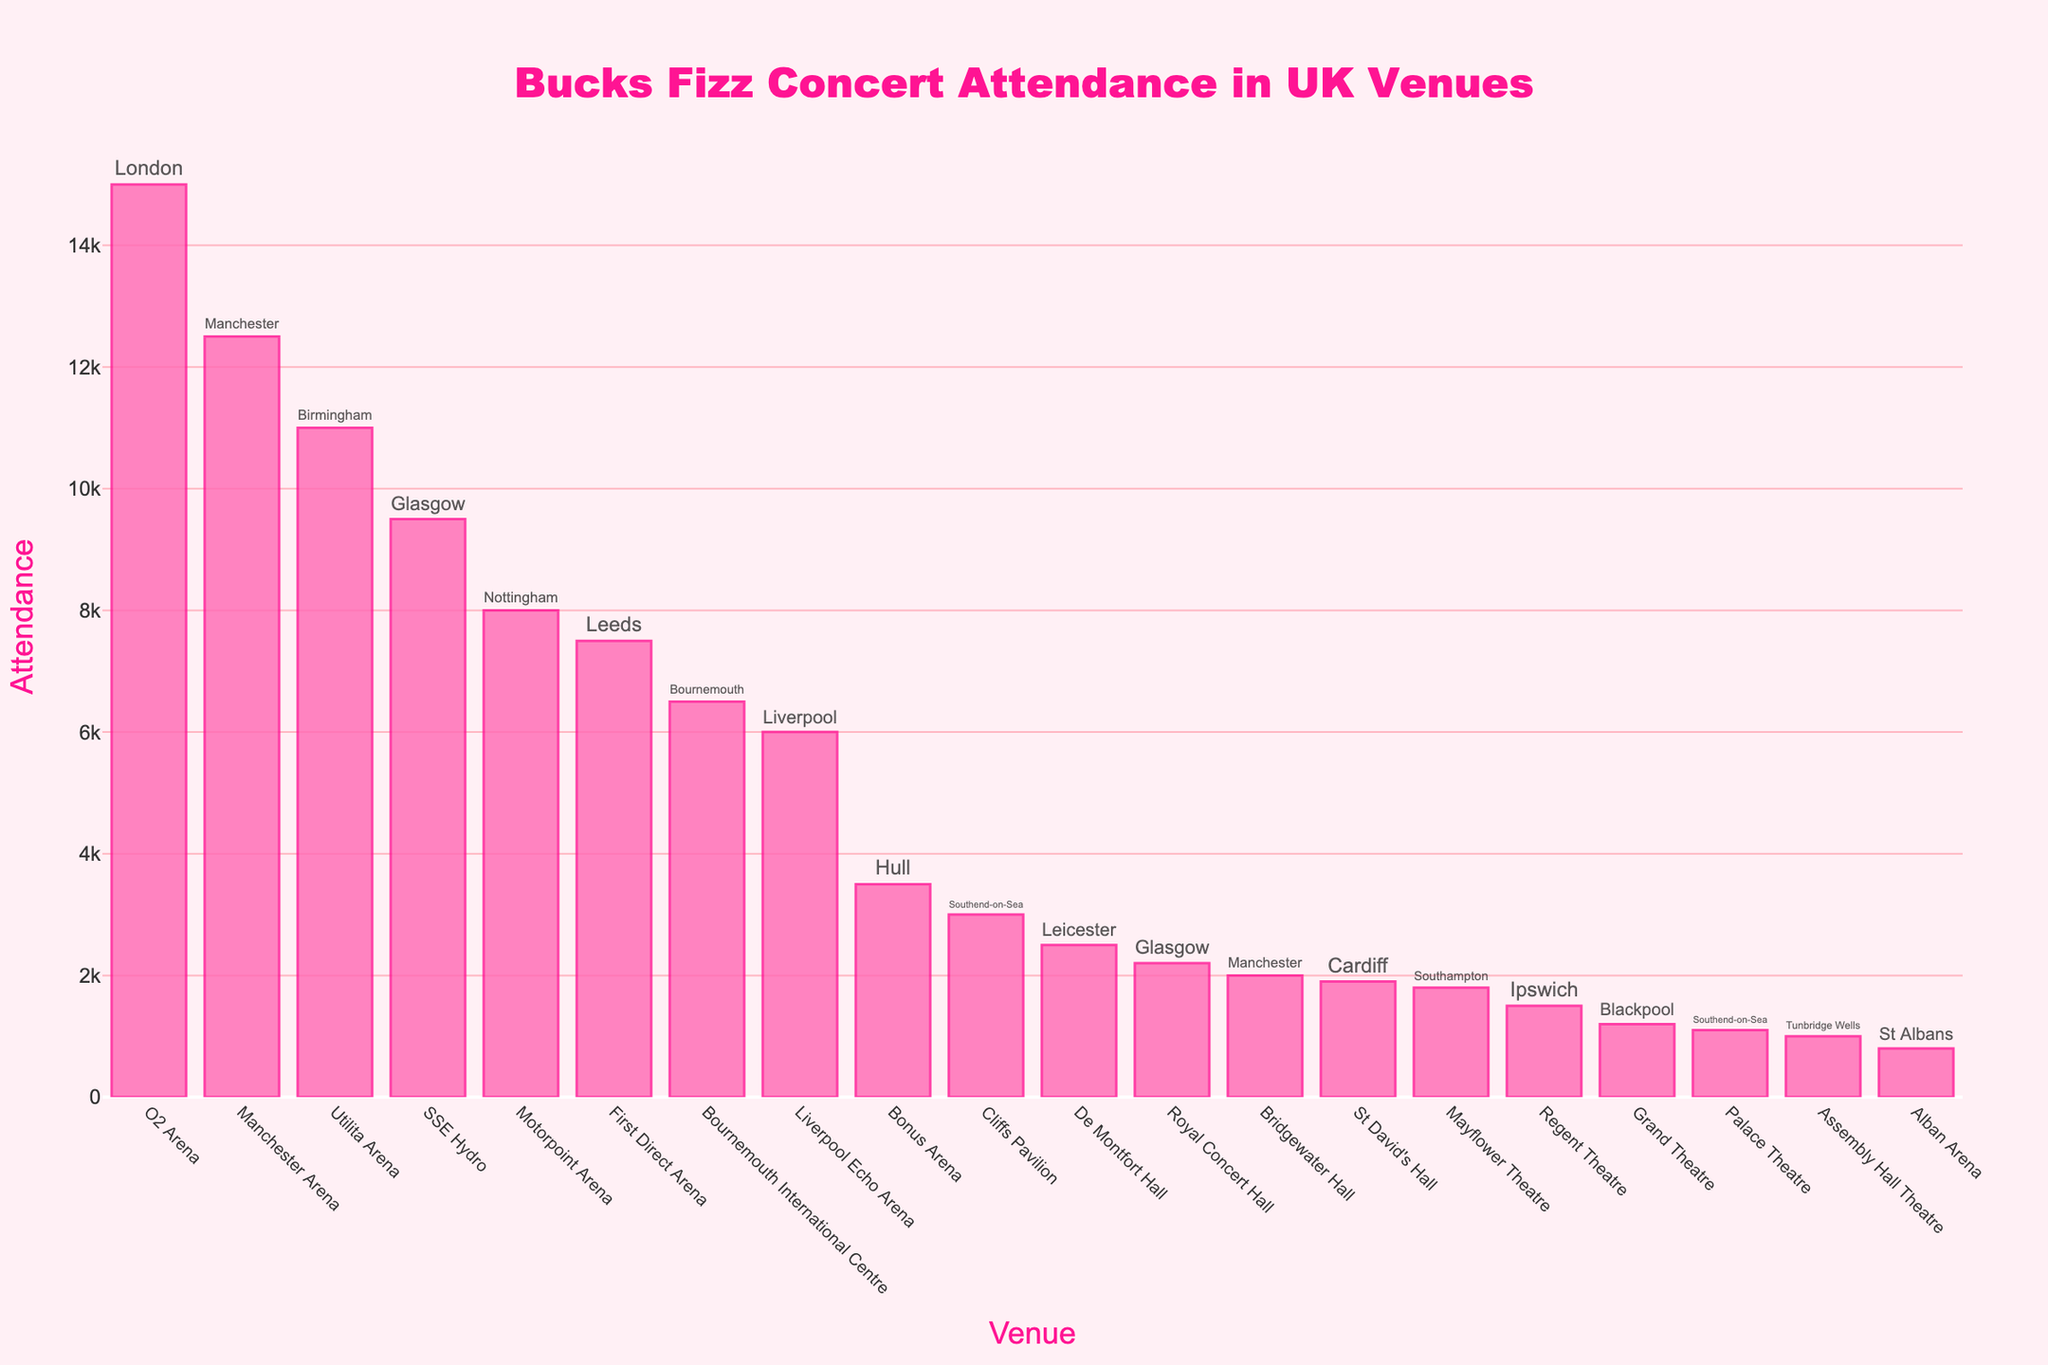Which venue has the highest attendance? The bar representing the O2 Arena in London is the tallest, indicating the highest attendance figure among all venues.
Answer: O2 Arena, London What's the total attendance for venues in Manchester? Add the attendance figures for Manchester Arena (12,500) and Bridgewater Hall (2,000). 12,500 + 2,000 = 14,500.
Answer: 14,500 Which city has the most venues listed? Count all the occurrences of each city in the text labels; Glasgow has two venues: SSE Hydro and Royal Concert Hall.
Answer: Glasgow What's the average attendance for venues in London, Manchester, and Birmingham? Sum the attendances for O2 Arena (15,000), Manchester Arena (12,500), Bridgewater Hall (2,000), and Utilita Arena (11,000) and divide by the number of venues, which is 4. (15,000 + 12,500 + 2,000 + 11,000) / 4 = 40,500 / 4 = 10,125.
Answer: 10,125 Which venue has a higher attendance: Bonus Arena in Hull or De Montfort Hall in Leicester? Compare the heights of the bars: Bonus Arena (3,500) and De Montfort Hall (2,500). Bonus Arena has a higher attendance than De Montfort Hall.
Answer: Bonus Arena, Hull Are the venues in Glasgow more popular than those in Liverpool in terms of attendance? Sum the attendance for Glasgow (SSE Hydro: 9,500 and Royal Concert Hall: 2,200) and compare it to Liverpool (Liverpool Echo Arena: 6,000). 9,500 + 2,200 = 11,700, which is greater than 6,000.
Answer: Yes What's the difference in attendance between the largest and smallest venues? Subtract the attendance of the smallest venue (Alban Arena: 800) from the largest venue (O2 Arena: 15,000). 15,000 - 800 = 14,200.
Answer: 14,200 Which venue has the lowest attendance? The shortest bar represents Alban Arena in St Albans, indicating the lowest attendance figure.
Answer: Alban Arena, St Albans How many venues have an attendance greater than 8,000? Count the bars with attendance figures above 8,000: O2 Arena, Manchester Arena, Utilita Arena, and SSE Hydro. There are 4 such venues.
Answer: 4 